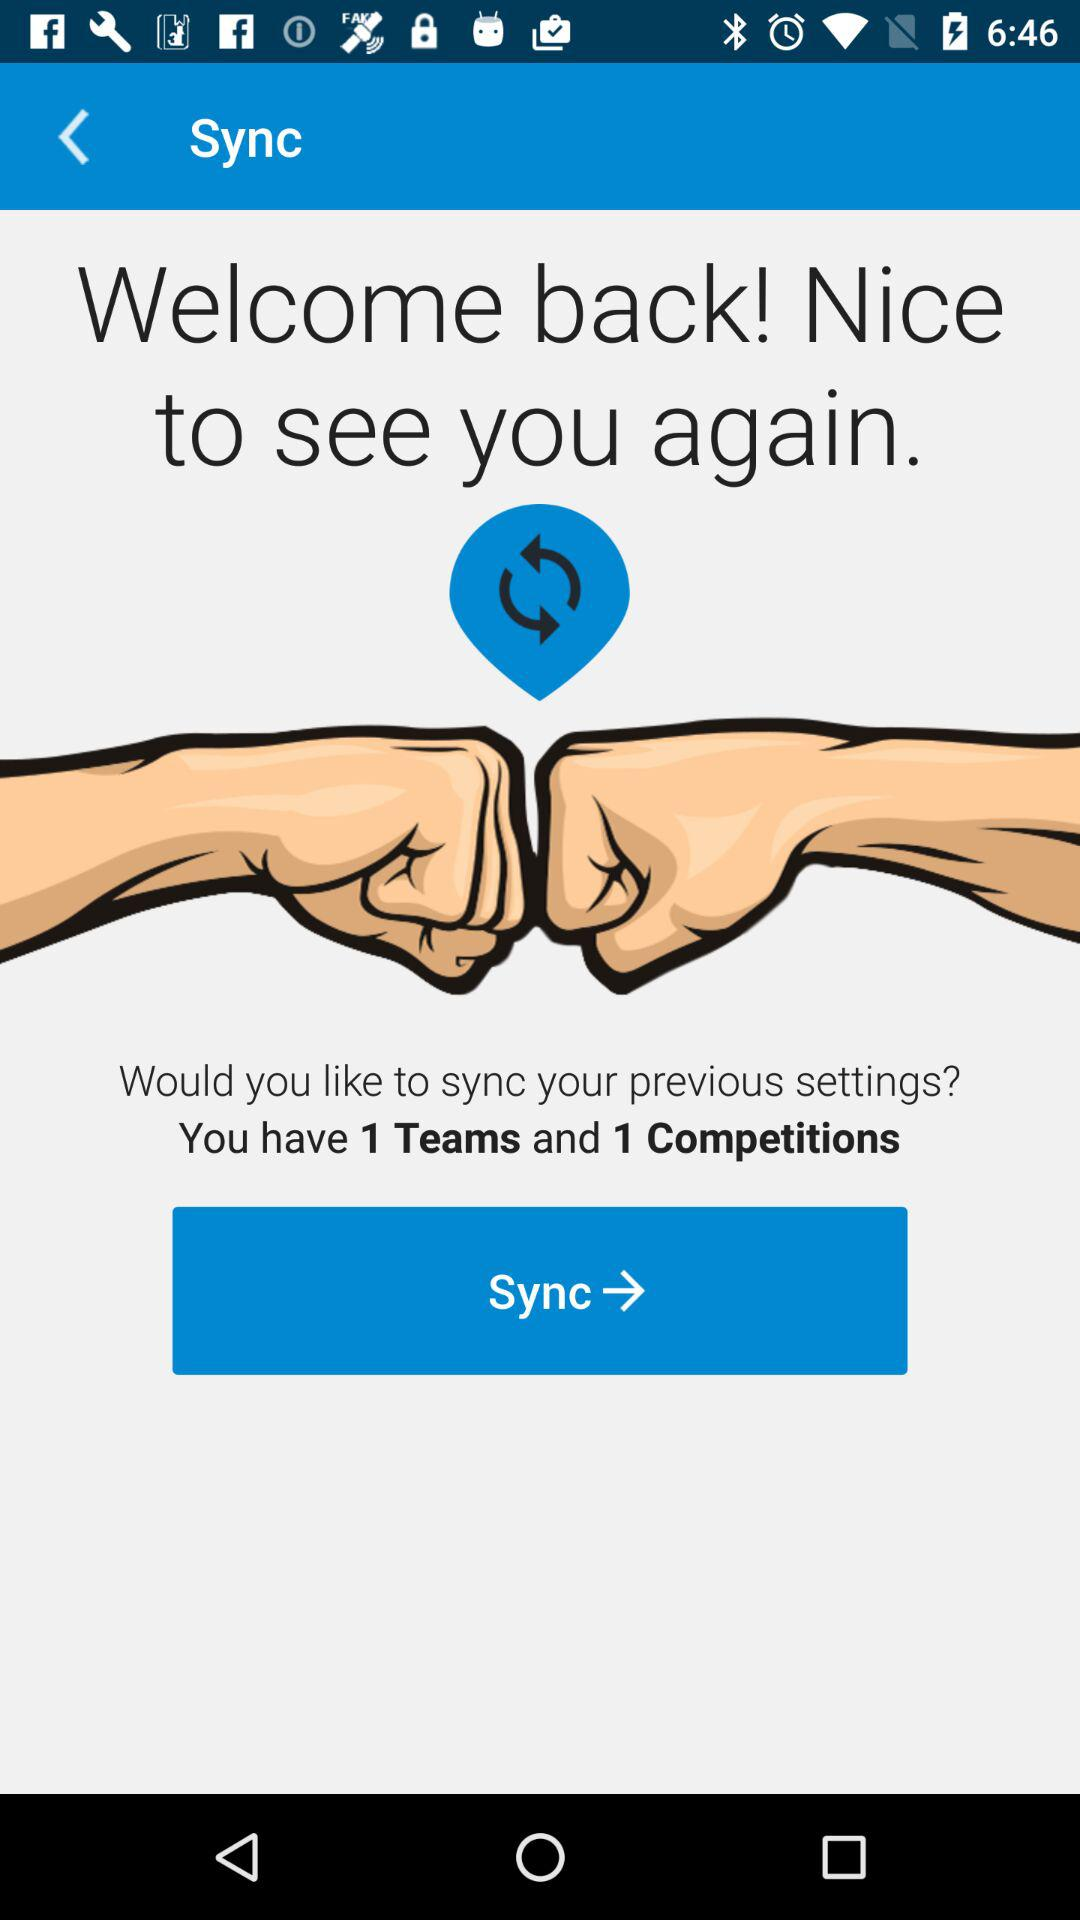When was the last settings sync?
When the provided information is insufficient, respond with <no answer>. <no answer> 